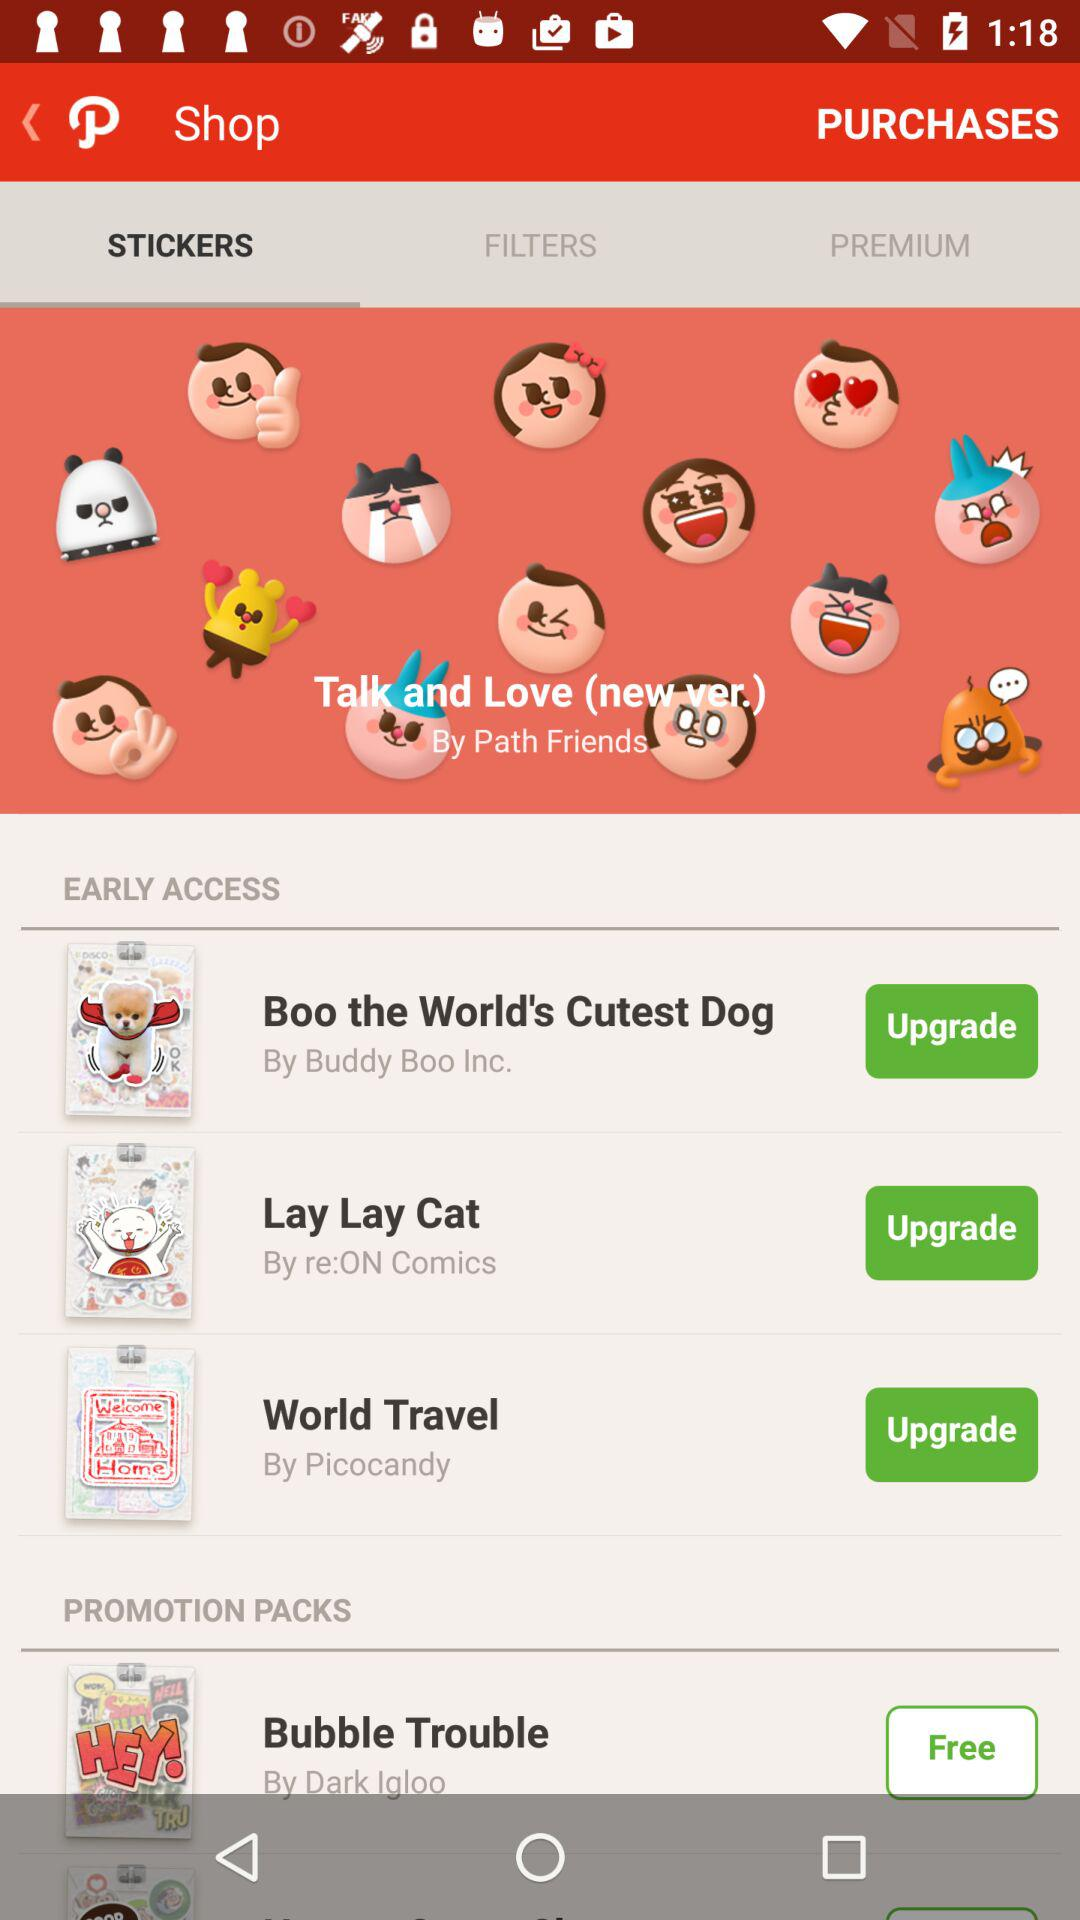Who developed Talk and Love stickers new version? Talk and Love sticker's new version is developed by Path Friends. 